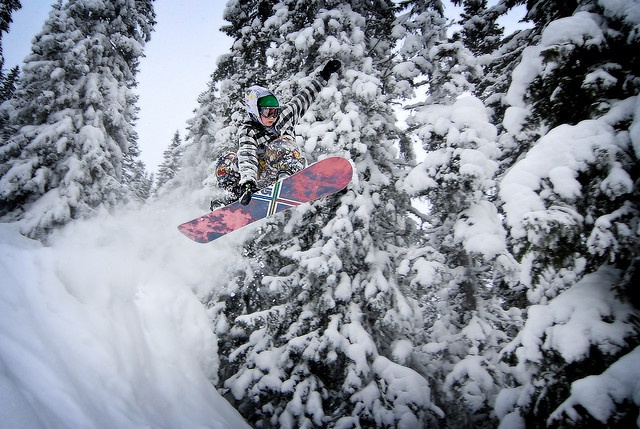Describe the objects in this image and their specific colors. I can see people in black, gray, darkgray, and lightgray tones and snowboard in black, gray, lightpink, and brown tones in this image. 